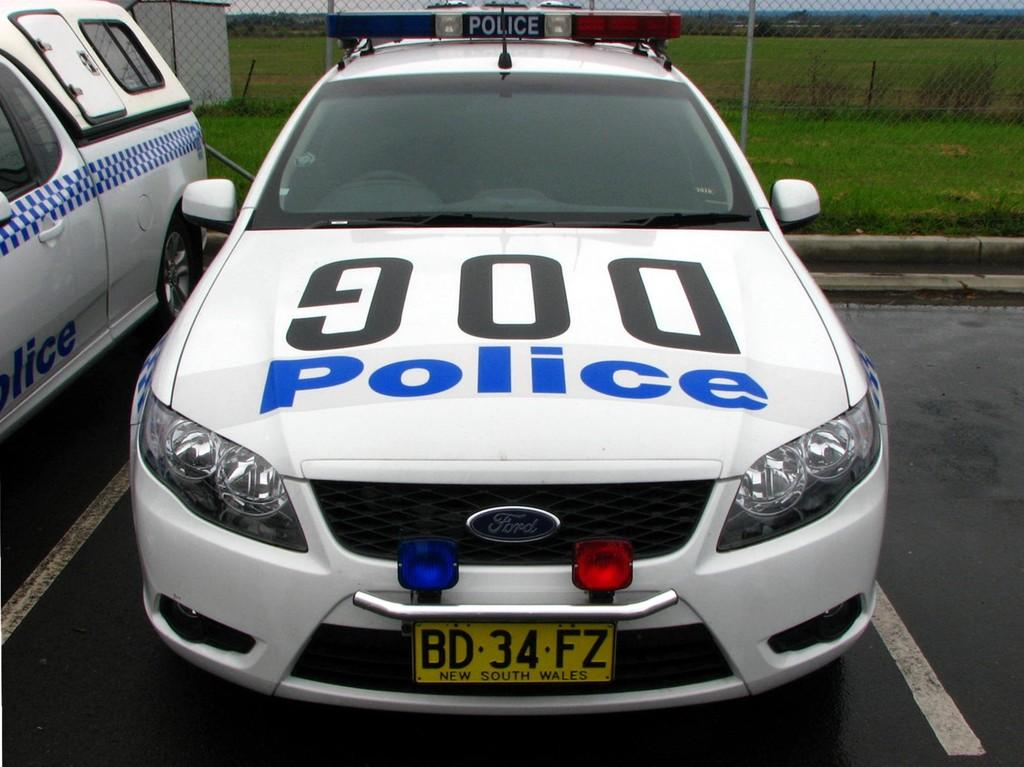What can be seen in the middle of the image? There are two cars parked on the road in the middle of the image. What is visible in the background of the image? There is a fencing in the background of the image. What type of sink can be seen in the image? There is no sink present in the image. Can you describe the behavior of the snail in the image? There is no snail present in the image, so its behavior cannot be described. 